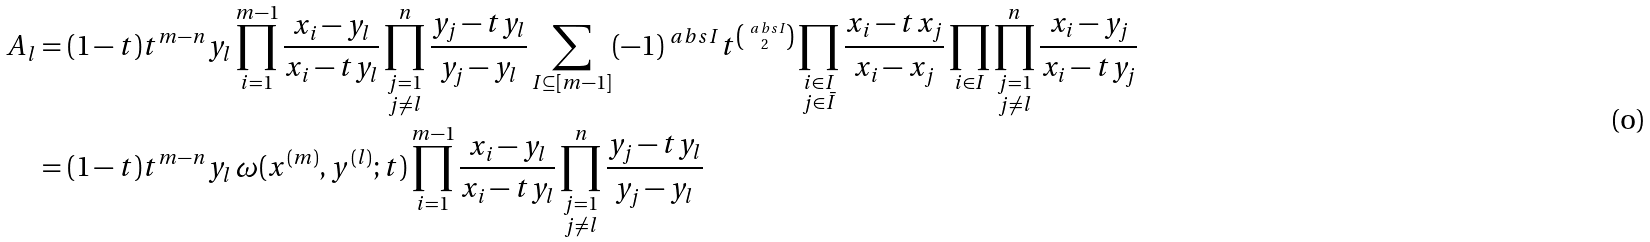<formula> <loc_0><loc_0><loc_500><loc_500>A _ { l } & = ( 1 - t ) t ^ { m - n } y _ { l } \prod _ { i = 1 } ^ { m - 1 } \frac { x _ { i } - y _ { l } } { x _ { i } - t y _ { l } } \prod _ { \substack { j = 1 \\ j \neq l } } ^ { n } \frac { y _ { j } - t y _ { l } } { y _ { j } - y _ { l } } \sum _ { I \subseteq [ m - 1 ] } ( - 1 ) ^ { \ a b s { I } } t ^ { \binom { \ a b s { I } } { 2 } } \prod _ { \substack { i \in I \\ j \in \bar { I } } } \frac { x _ { i } - t x _ { j } } { x _ { i } - x _ { j } } \prod _ { i \in I } \prod _ { \substack { j = 1 \\ j \neq l } } ^ { n } \frac { x _ { i } - y _ { j } } { x _ { i } - t y _ { j } } \\ & = ( 1 - t ) t ^ { m - n } y _ { l } \, \omega ( x ^ { ( m ) } , y ^ { ( l ) } ; t ) \prod _ { i = 1 } ^ { m - 1 } \frac { x _ { i } - y _ { l } } { x _ { i } - t y _ { l } } \prod _ { \substack { j = 1 \\ j \neq l } } ^ { n } \frac { y _ { j } - t y _ { l } } { y _ { j } - y _ { l } }</formula> 